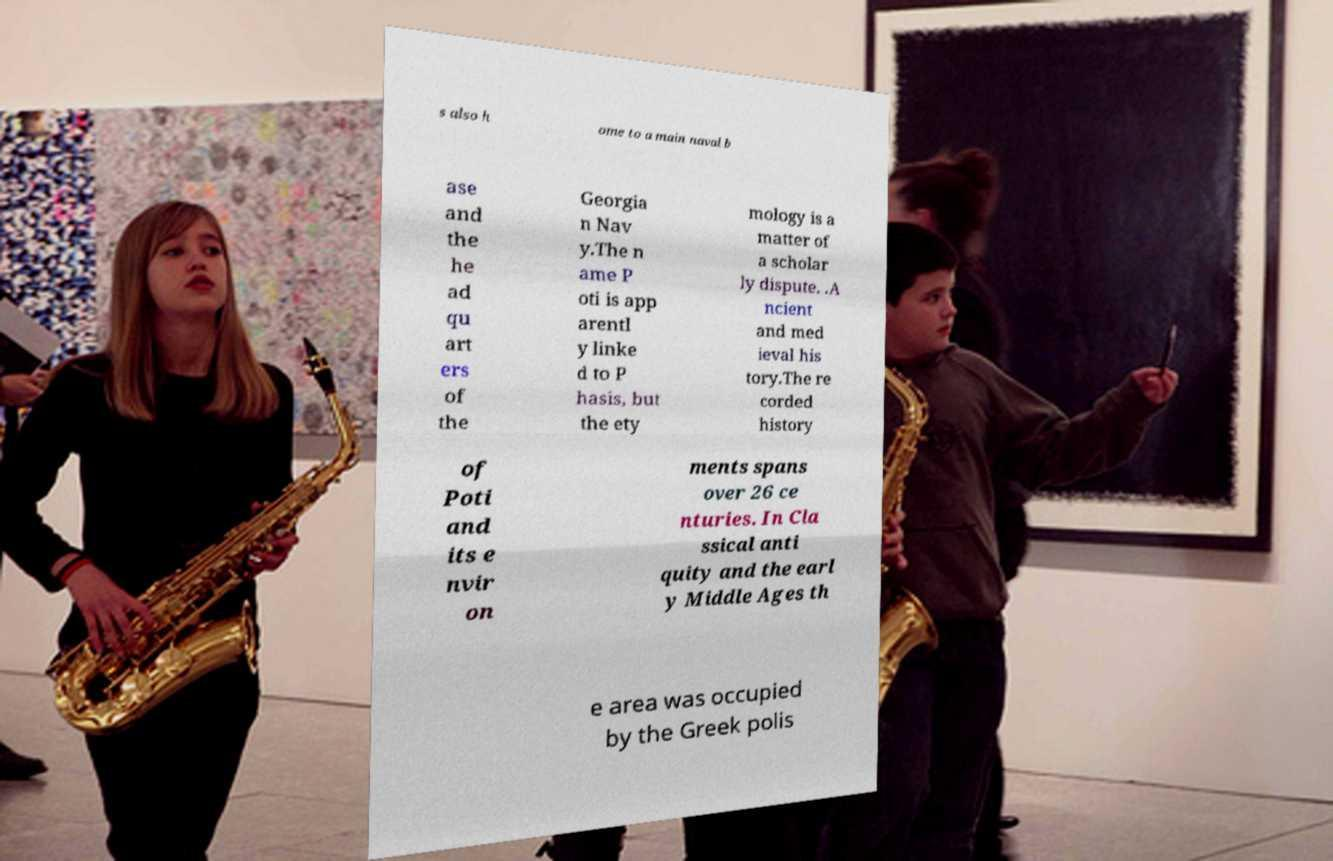Could you assist in decoding the text presented in this image and type it out clearly? s also h ome to a main naval b ase and the he ad qu art ers of the Georgia n Nav y.The n ame P oti is app arentl y linke d to P hasis, but the ety mology is a matter of a scholar ly dispute. .A ncient and med ieval his tory.The re corded history of Poti and its e nvir on ments spans over 26 ce nturies. In Cla ssical anti quity and the earl y Middle Ages th e area was occupied by the Greek polis 